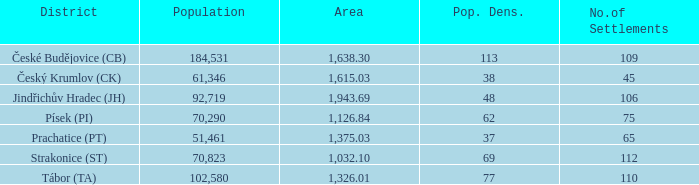How many settlements within český krumlov (ck) possess a population density of more than 38? None. 